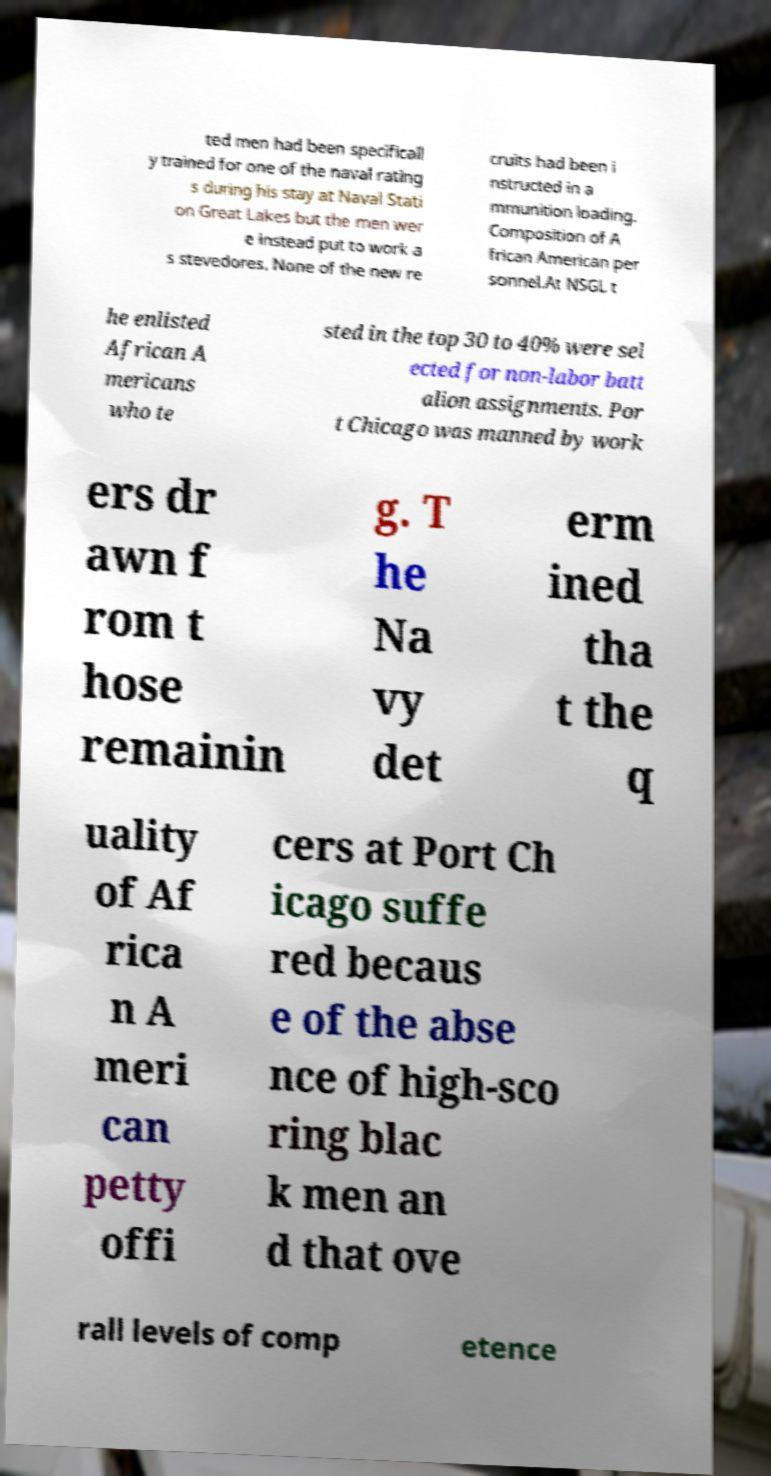I need the written content from this picture converted into text. Can you do that? ted men had been specificall y trained for one of the naval rating s during his stay at Naval Stati on Great Lakes but the men wer e instead put to work a s stevedores. None of the new re cruits had been i nstructed in a mmunition loading. Composition of A frican American per sonnel.At NSGL t he enlisted African A mericans who te sted in the top 30 to 40% were sel ected for non-labor batt alion assignments. Por t Chicago was manned by work ers dr awn f rom t hose remainin g. T he Na vy det erm ined tha t the q uality of Af rica n A meri can petty offi cers at Port Ch icago suffe red becaus e of the abse nce of high-sco ring blac k men an d that ove rall levels of comp etence 